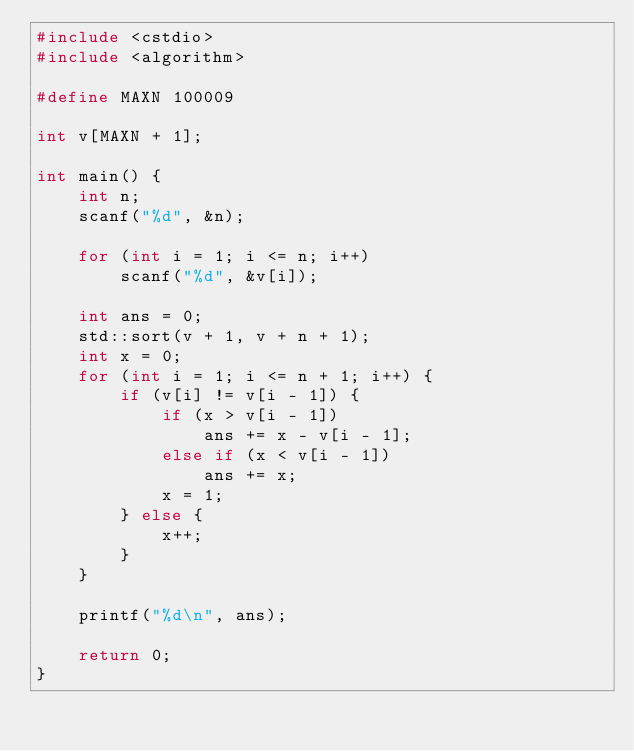<code> <loc_0><loc_0><loc_500><loc_500><_C++_>#include <cstdio>
#include <algorithm>

#define MAXN 100009

int v[MAXN + 1];

int main() {
    int n;
    scanf("%d", &n);

    for (int i = 1; i <= n; i++)
        scanf("%d", &v[i]);

    int ans = 0;
    std::sort(v + 1, v + n + 1);
    int x = 0;
    for (int i = 1; i <= n + 1; i++) {
        if (v[i] != v[i - 1]) {
            if (x > v[i - 1])
                ans += x - v[i - 1];
            else if (x < v[i - 1])
                ans += x;
            x = 1;
        } else {
            x++;
        }
    }

    printf("%d\n", ans);

    return 0;
}
</code> 